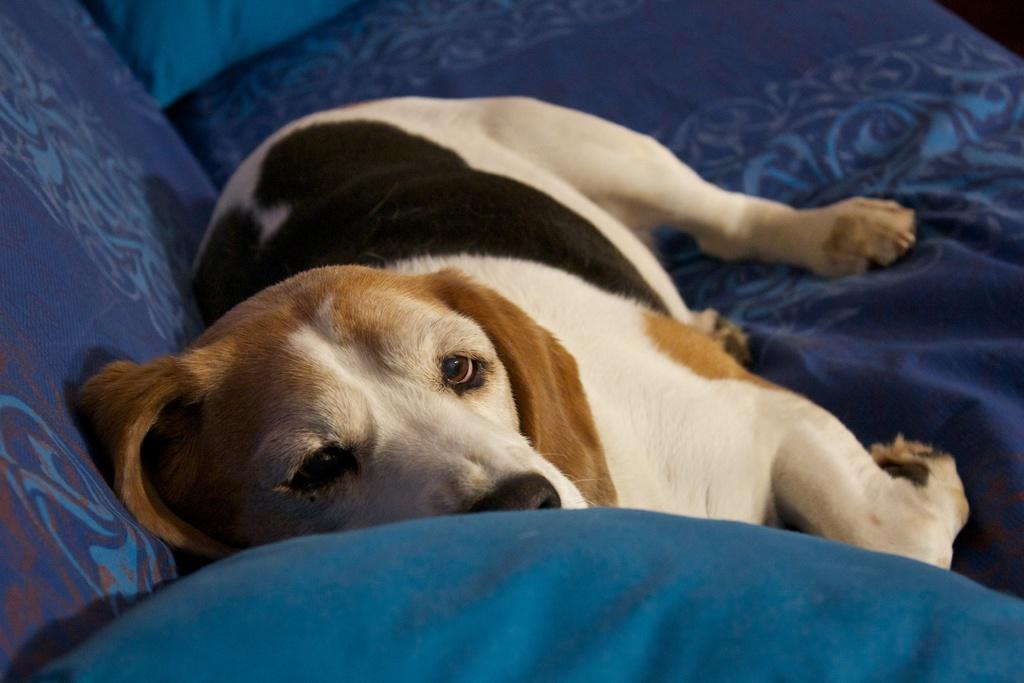In one or two sentences, can you explain what this image depicts? In this image I can see the dog in white, cream and black color and the dog is on the couch and the couch is in blue color. 